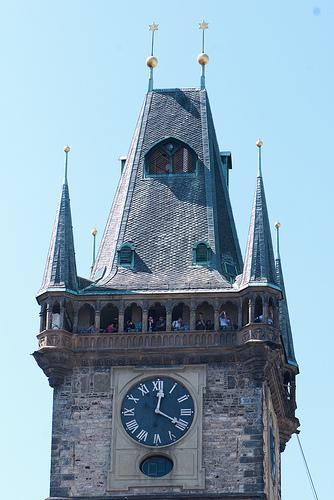Question: what time is it?
Choices:
A. 0945.
B. 1130.
C. 0559.
D. 1220.
Answer with the letter. Answer: D Question: who is in the tower?
Choices:
A. A guard.
B. People.
C. The janitor.
D. The princess.
Answer with the letter. Answer: B Question: why are they standing up there?
Choices:
A. To take a picture.
B. To observe.
C. To watch the sunset.
D. To avoid direct sunlight.
Answer with the letter. Answer: B Question: what is the bulding?
Choices:
A. Office space.
B. Radio relay.
C. Clock tower.
D. Monument.
Answer with the letter. Answer: C 